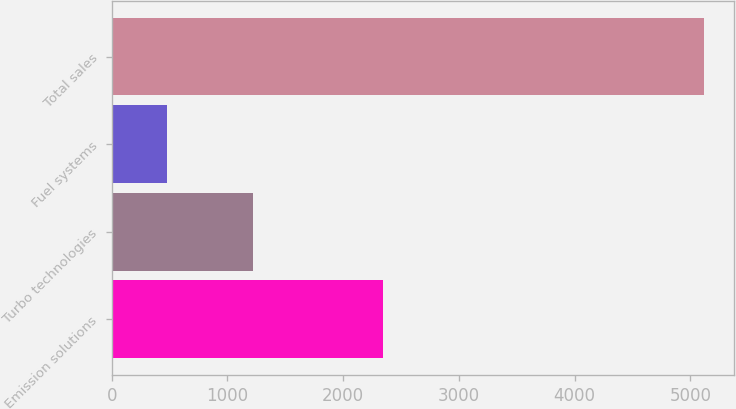Convert chart. <chart><loc_0><loc_0><loc_500><loc_500><bar_chart><fcel>Emission solutions<fcel>Turbo technologies<fcel>Fuel systems<fcel>Total sales<nl><fcel>2343<fcel>1222<fcel>478<fcel>5118<nl></chart> 